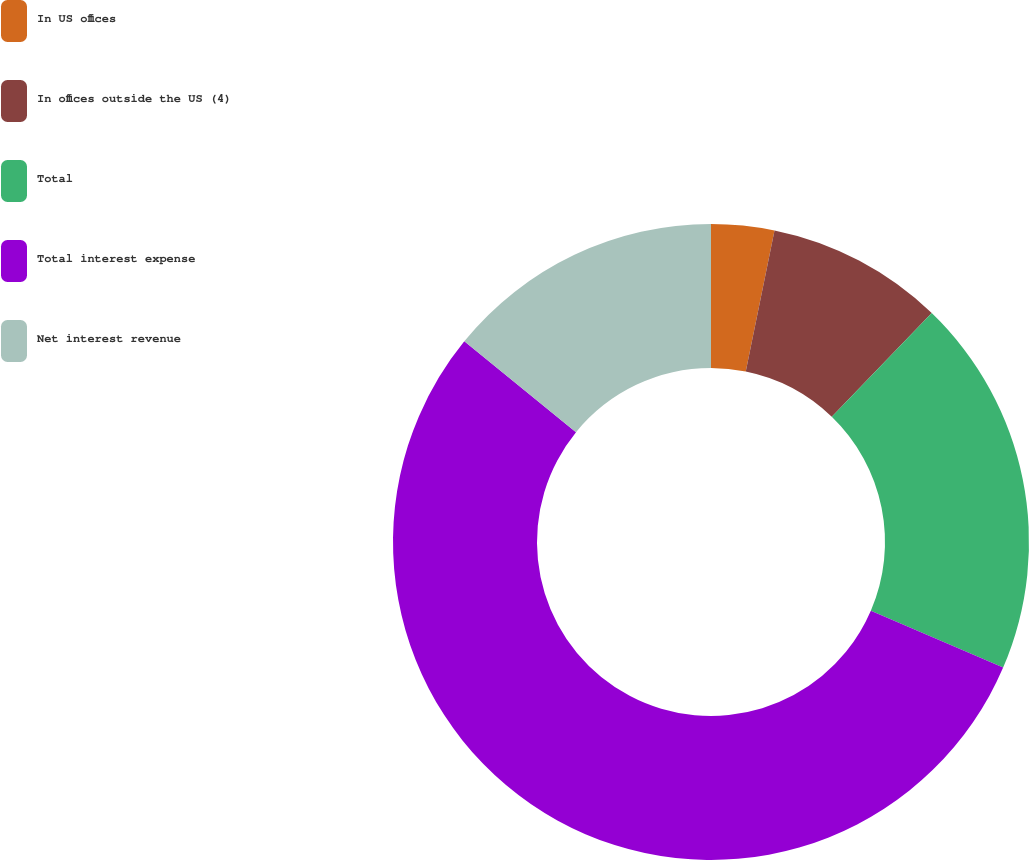Convert chart. <chart><loc_0><loc_0><loc_500><loc_500><pie_chart><fcel>In US offices<fcel>In offices outside the US (4)<fcel>Total<fcel>Total interest expense<fcel>Net interest revenue<nl><fcel>3.2%<fcel>9.01%<fcel>19.25%<fcel>54.4%<fcel>14.13%<nl></chart> 